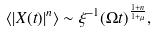Convert formula to latex. <formula><loc_0><loc_0><loc_500><loc_500>\langle | X ( t ) | ^ { n } \rangle \sim \xi ^ { - 1 } ( \Omega t ) ^ { \frac { 1 + n } { 1 + \mu } } ,</formula> 